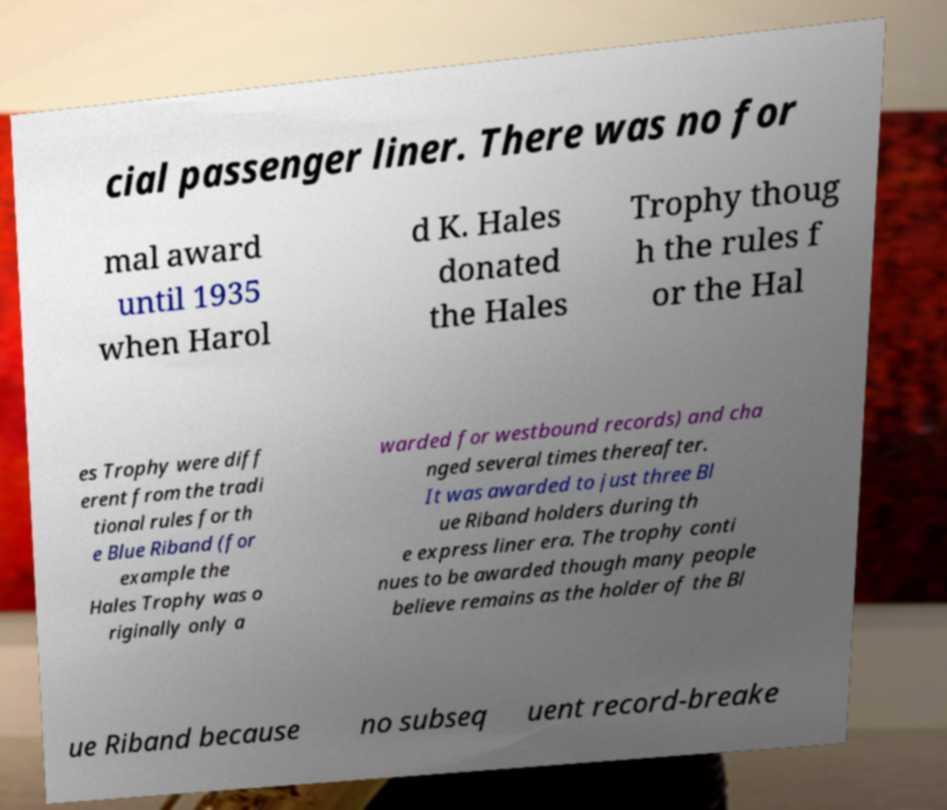What messages or text are displayed in this image? I need them in a readable, typed format. cial passenger liner. There was no for mal award until 1935 when Harol d K. Hales donated the Hales Trophy thoug h the rules f or the Hal es Trophy were diff erent from the tradi tional rules for th e Blue Riband (for example the Hales Trophy was o riginally only a warded for westbound records) and cha nged several times thereafter. It was awarded to just three Bl ue Riband holders during th e express liner era. The trophy conti nues to be awarded though many people believe remains as the holder of the Bl ue Riband because no subseq uent record-breake 